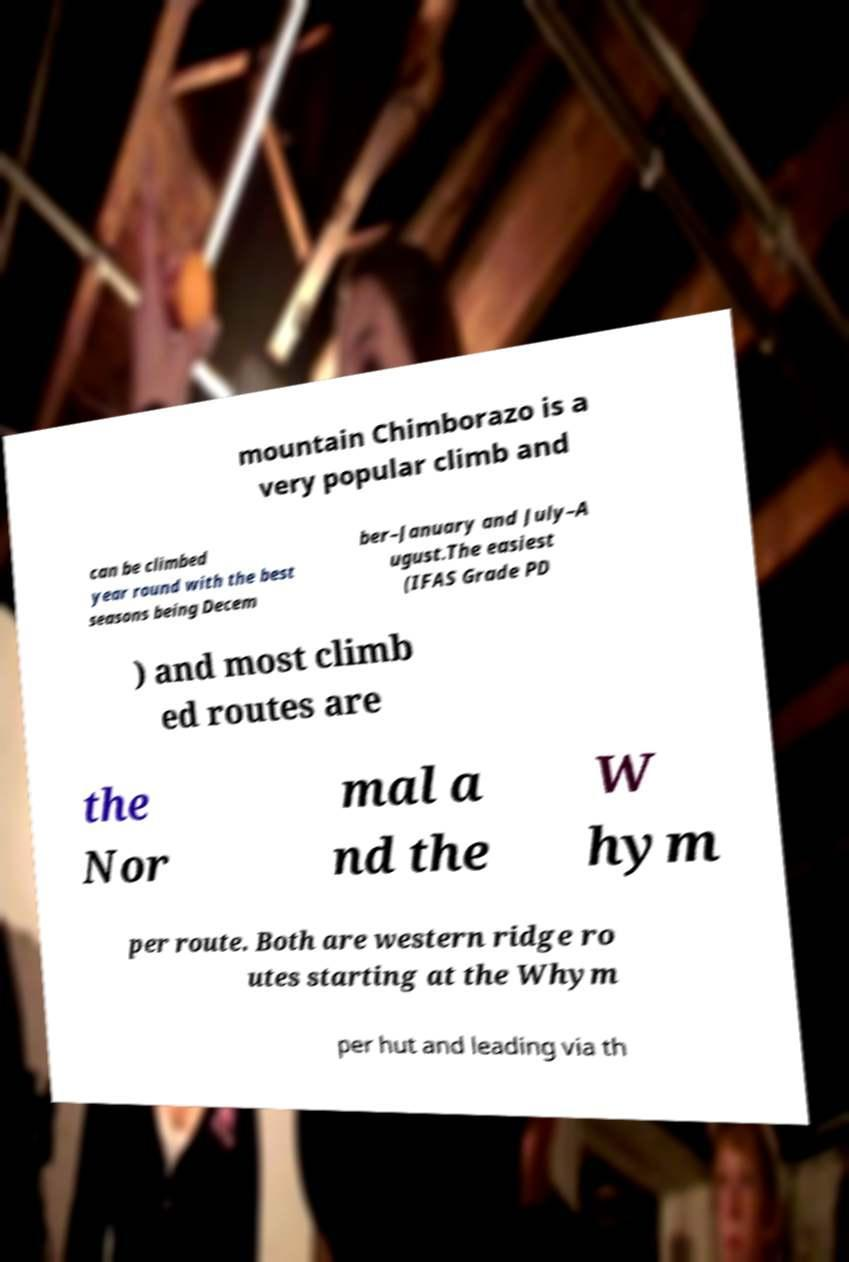Please identify and transcribe the text found in this image. mountain Chimborazo is a very popular climb and can be climbed year round with the best seasons being Decem ber–January and July–A ugust.The easiest (IFAS Grade PD ) and most climb ed routes are the Nor mal a nd the W hym per route. Both are western ridge ro utes starting at the Whym per hut and leading via th 